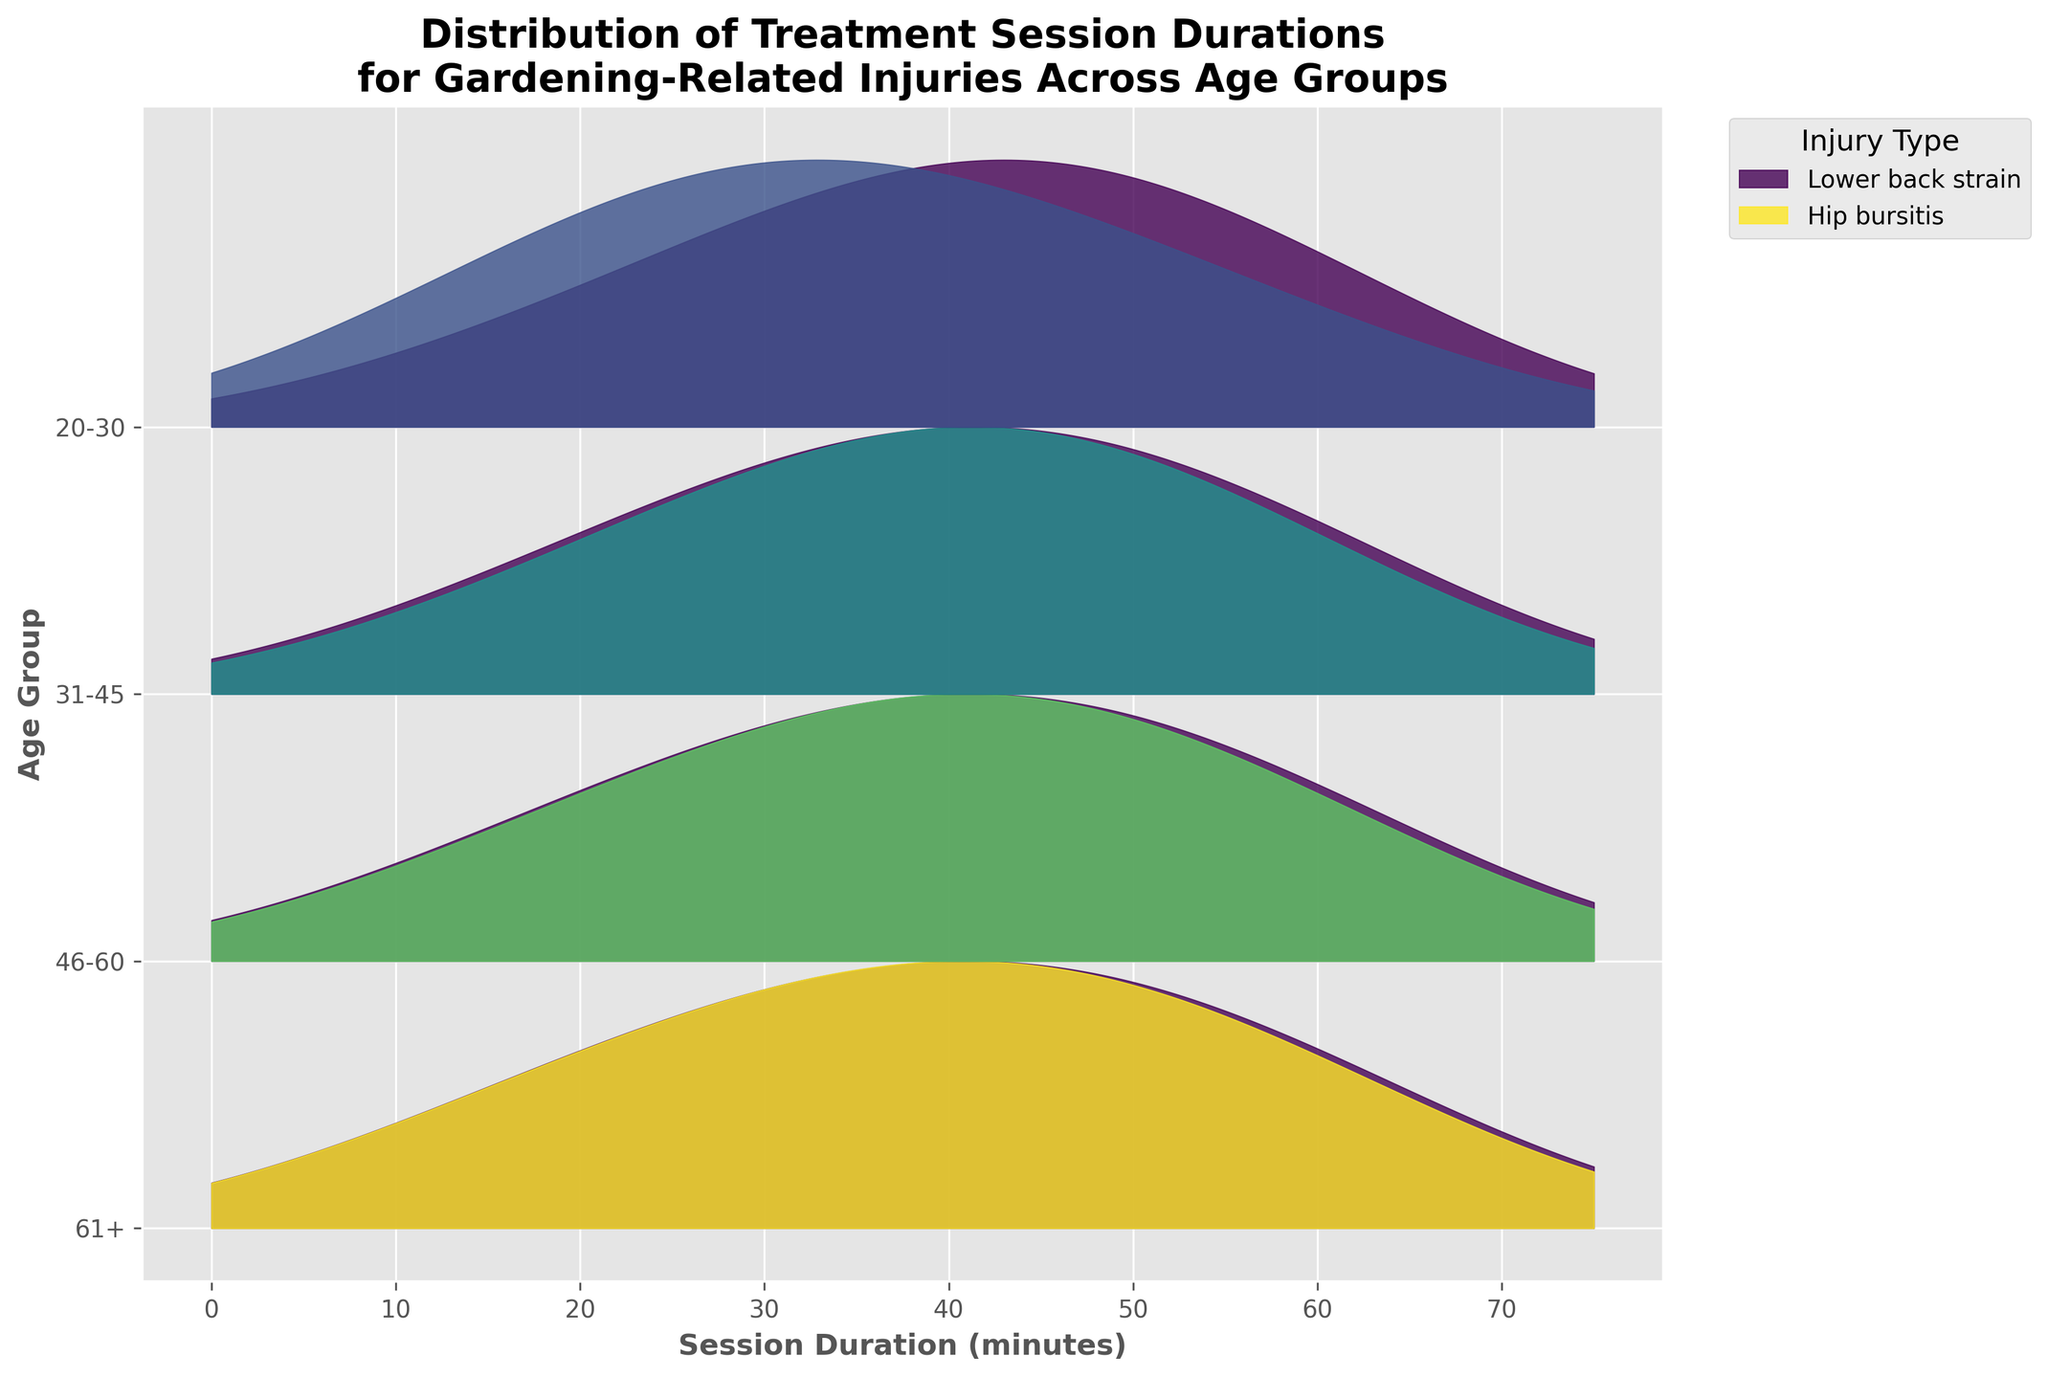What is the title of the plot? The title of the plot is prominently displayed at the top and reads "Distribution of Treatment Session Durations for Gardening-Related Injuries Across Age Groups." This is directly observable.
Answer: Distribution of Treatment Session Durations for Gardening-Related Injuries Across Age Groups Which age group shows the highest density for a 60-minute session duration for Lower back strain? The 60-minute session for Lower back strain shows higher density in the "61+" age group compared to other age groups. This can be inferred by looking at the height of the peak for the 60-minute session in the "61+" ridgeline compared to others.
Answer: 61+ Which injury type has the second most colors in the plot? The "Lower back strain" injury type has the most colors as it appears in all age groups. The second most widespread injury is noted by observing the colors representing different injuries. This color is for "Shoulder tendinitis," present in age group 46-60.
Answer: Shoulder tendinitis For the 31-45 age group, which injury type has the highest density in a 45-minute session duration? By closely examining the ridgeline plot for the 31-45 age group, the 45-minute session duration peak is higher for "Lower back strain" compared to "Knee pain," indicating a higher density for "Lower back strain."
Answer: Lower back strain How many different injury types are presented in the figure? By identifying the unique injury types represented in the legend, you can count the different injuries shown. They are "Lower back strain," "Wrist sprain," "Knee pain," "Shoulder tendinitis," and "Hip bursitis," making a total of five injury types.
Answer: 5 What is the general trend for session duration density from younger to older age groups? Observing the ridgeline lines, there is a trend where densities and session durations for injuries like "Lower back strain" increase as age groups get older. This implies that older age groups tend to have longer session durations with higher densities.
Answer: Longer and higher density sessions in older age groups What age group has the narrowest distribution for "Knee pain"? Focusing on the ridgeline plot, "Knee pain" distribution is only evident in the 31-45 age group. From this single group presence, one can tell that the distribution is narrowest in 31-45 as it doesn't appear in others.
Answer: 31-45 Compare the density peaks of "Wrist sprain" and "Hip bursitis" for any noticeable difference. By comparing the density heights, we can see "Wrist sprain" in the younger age groups (20-30) and "Hip bursitis" in the oldest age group (61+). The highest density peak of "Hip bursitis" appears to be slightly higher than that of "Wrist sprain."
Answer: Hip bursitis higher density peak in 61+ What session duration for "Lower back strain" in the 46-60 age group has the highest density? Looking closely at the 46-60 age group's ridgeline for "Lower back strain," the highest peak (density) is found at the 45-minute session duration.
Answer: 45 minutes 